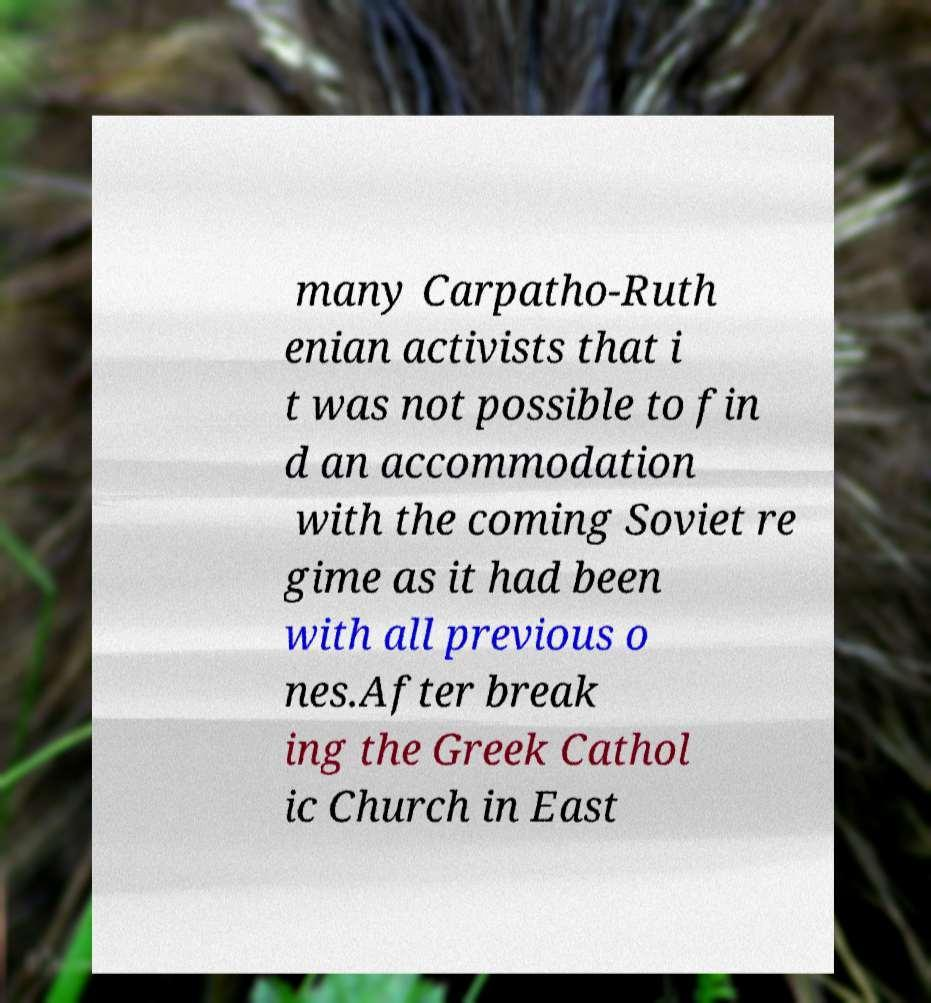Could you extract and type out the text from this image? many Carpatho-Ruth enian activists that i t was not possible to fin d an accommodation with the coming Soviet re gime as it had been with all previous o nes.After break ing the Greek Cathol ic Church in East 